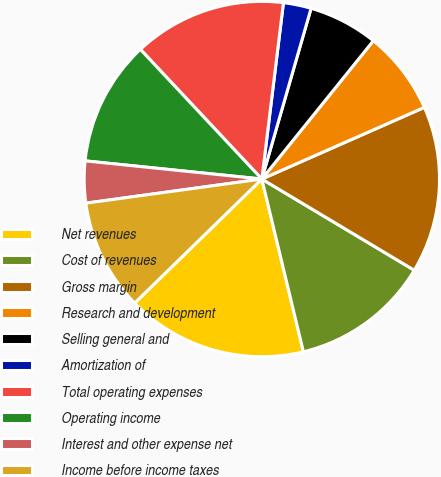Convert chart. <chart><loc_0><loc_0><loc_500><loc_500><pie_chart><fcel>Net revenues<fcel>Cost of revenues<fcel>Gross margin<fcel>Research and development<fcel>Selling general and<fcel>Amortization of<fcel>Total operating expenses<fcel>Operating income<fcel>Interest and other expense net<fcel>Income before income taxes<nl><fcel>16.46%<fcel>12.66%<fcel>15.19%<fcel>7.59%<fcel>6.33%<fcel>2.53%<fcel>13.92%<fcel>11.39%<fcel>3.8%<fcel>10.13%<nl></chart> 